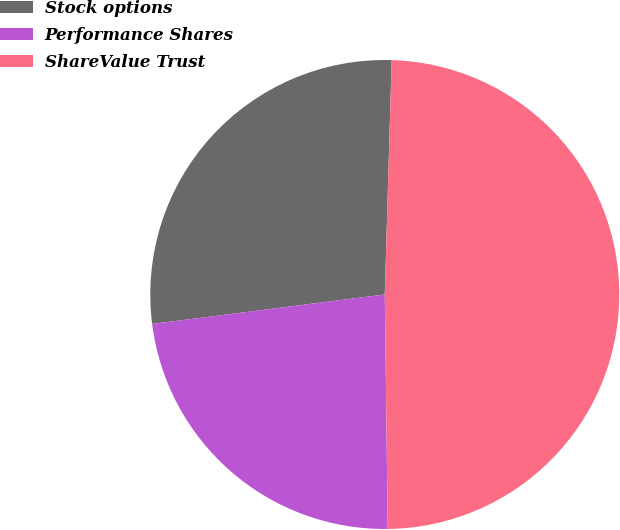Convert chart. <chart><loc_0><loc_0><loc_500><loc_500><pie_chart><fcel>Stock options<fcel>Performance Shares<fcel>ShareValue Trust<nl><fcel>27.47%<fcel>23.2%<fcel>49.33%<nl></chart> 